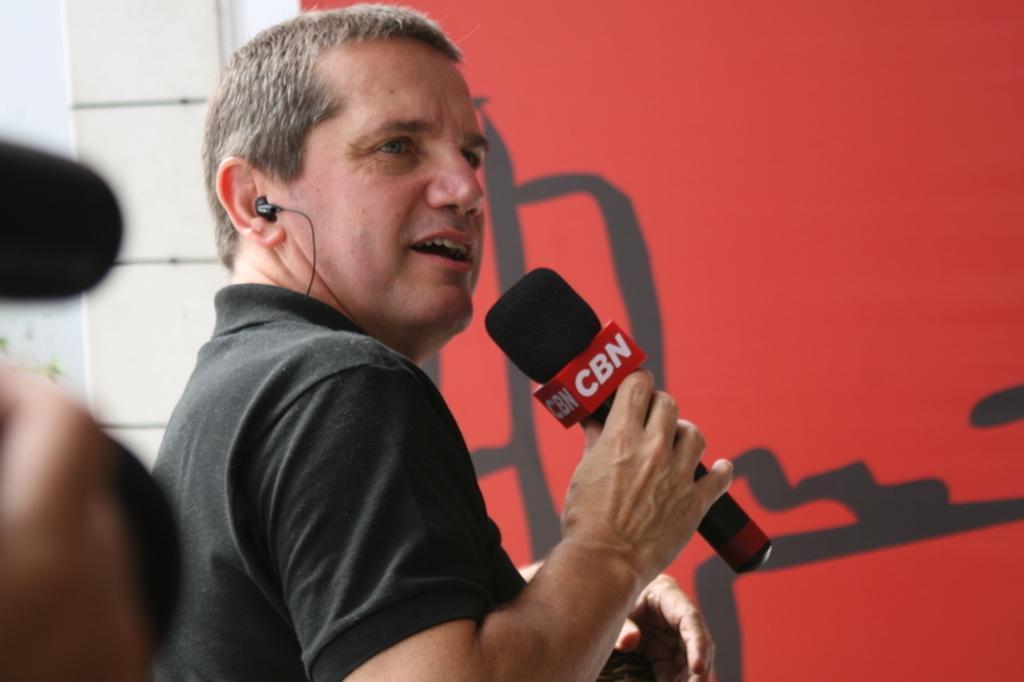Please provide a concise description of this image. Here is a man standing and holding mike in his hand. He put headphone in his ear. At background I can see a red color poster. 